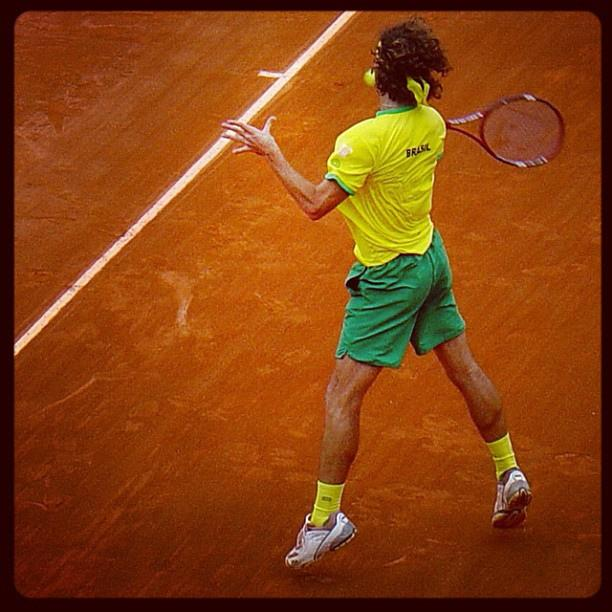What is this man doing? playing tennis 